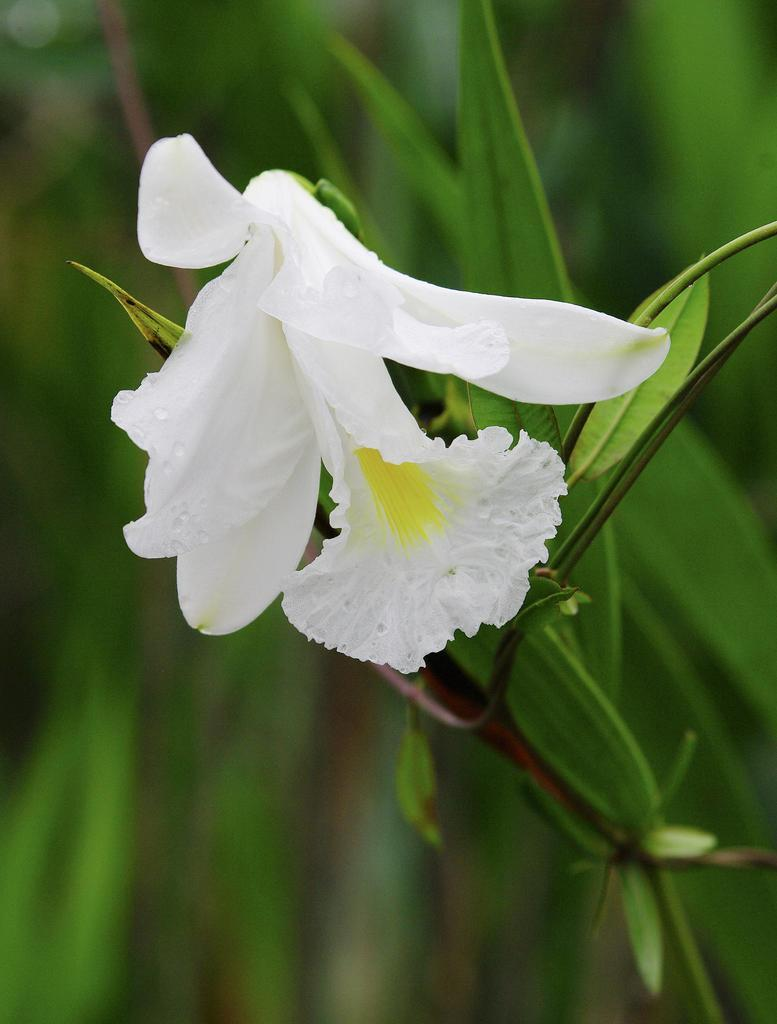What type of flower can be seen on the plant in the image? There is a white flower on a plant in the image. What else can be seen on the plant besides the flower? Leaves are visible in the image. What type of approval is required to clean the sink in the image? There is no sink present in the image, so the question of approval for cleaning it is not applicable. 